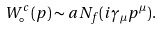<formula> <loc_0><loc_0><loc_500><loc_500>W ^ { c } _ { \circ } ( p ) \sim a N _ { f } ( i \gamma _ { \mu } p ^ { \mu } ) .</formula> 